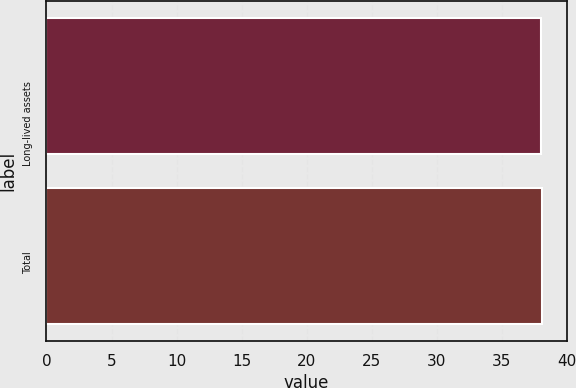Convert chart. <chart><loc_0><loc_0><loc_500><loc_500><bar_chart><fcel>Long-lived assets<fcel>Total<nl><fcel>38<fcel>38.1<nl></chart> 